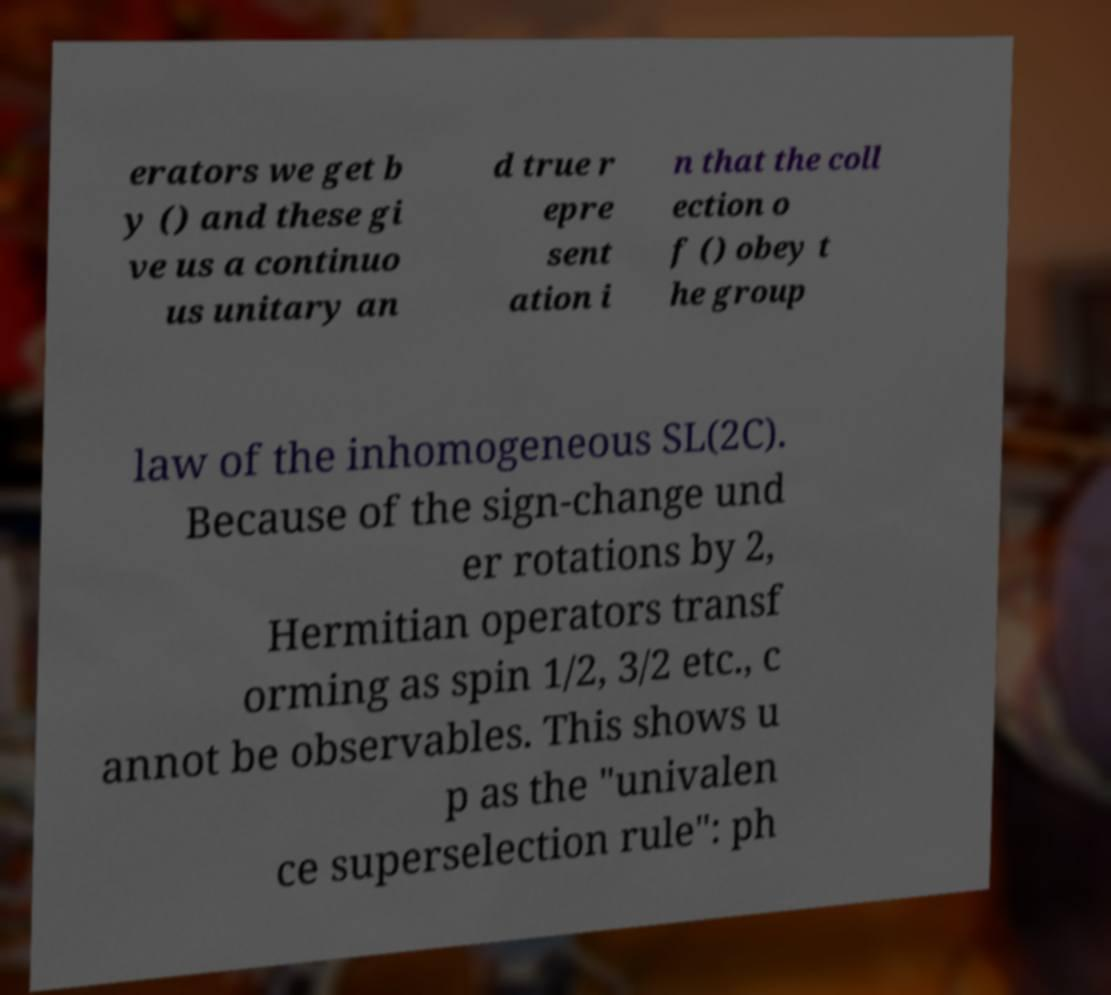Could you extract and type out the text from this image? erators we get b y () and these gi ve us a continuo us unitary an d true r epre sent ation i n that the coll ection o f () obey t he group law of the inhomogeneous SL(2C). Because of the sign-change und er rotations by 2, Hermitian operators transf orming as spin 1/2, 3/2 etc., c annot be observables. This shows u p as the "univalen ce superselection rule": ph 